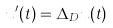<formula> <loc_0><loc_0><loc_500><loc_500>u ^ { \prime } ( t ) = \Delta _ { D } u ( t )</formula> 